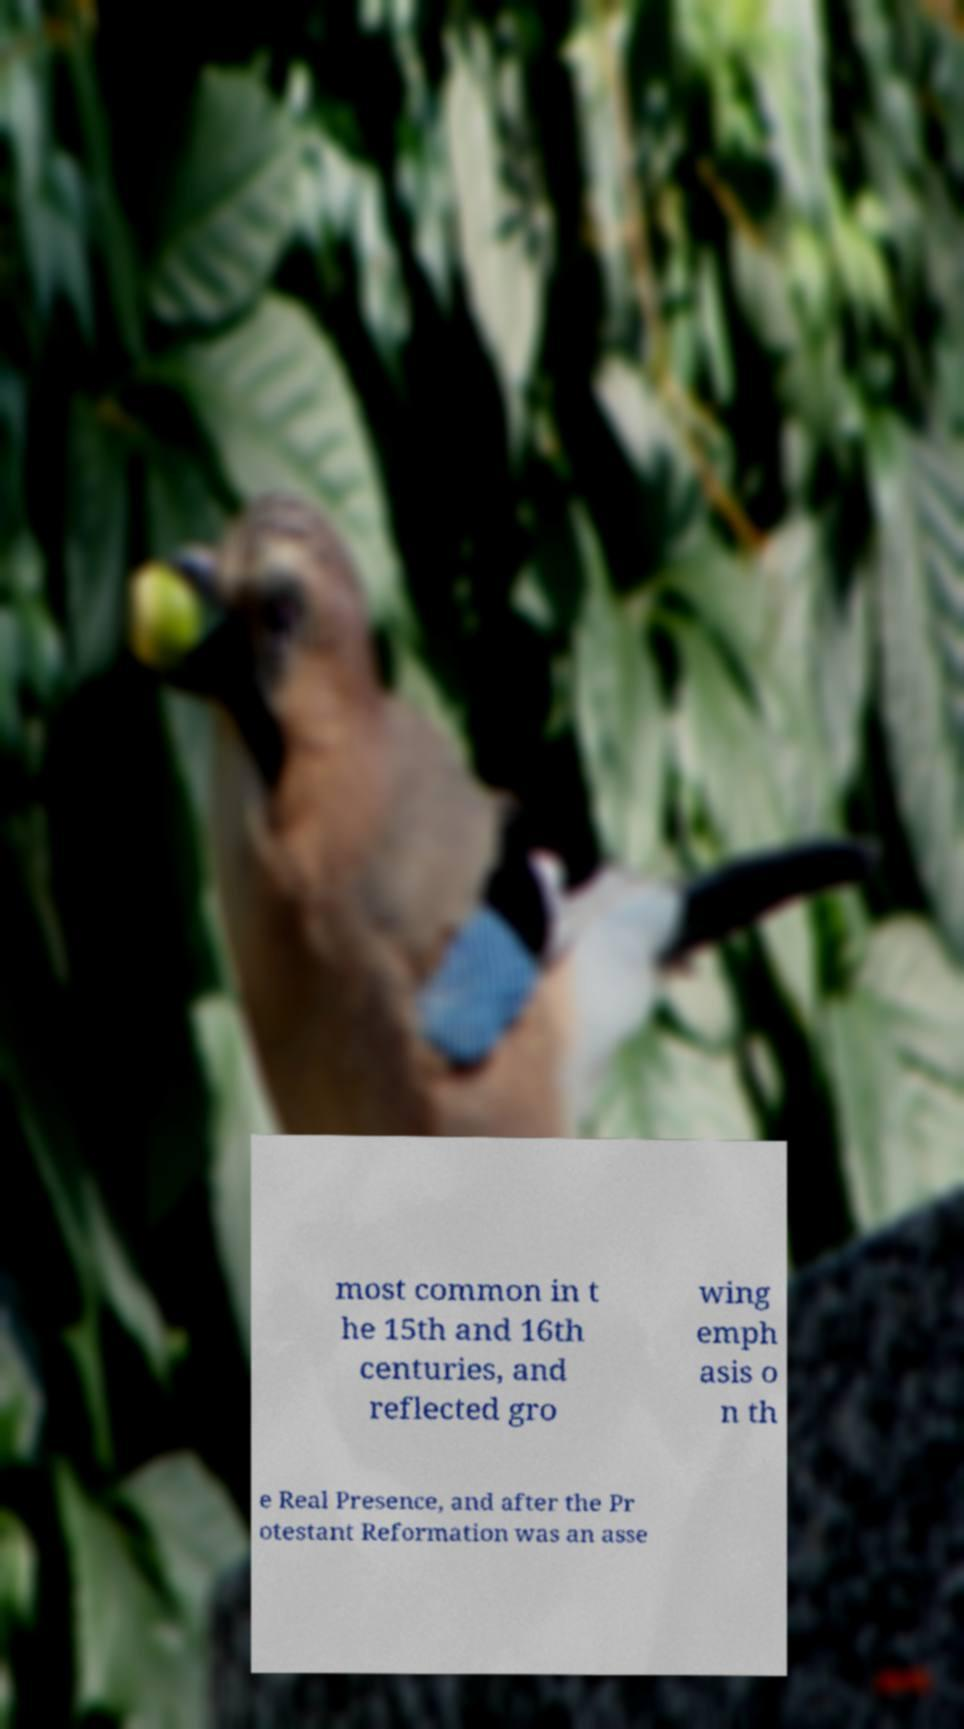Please identify and transcribe the text found in this image. most common in t he 15th and 16th centuries, and reflected gro wing emph asis o n th e Real Presence, and after the Pr otestant Reformation was an asse 